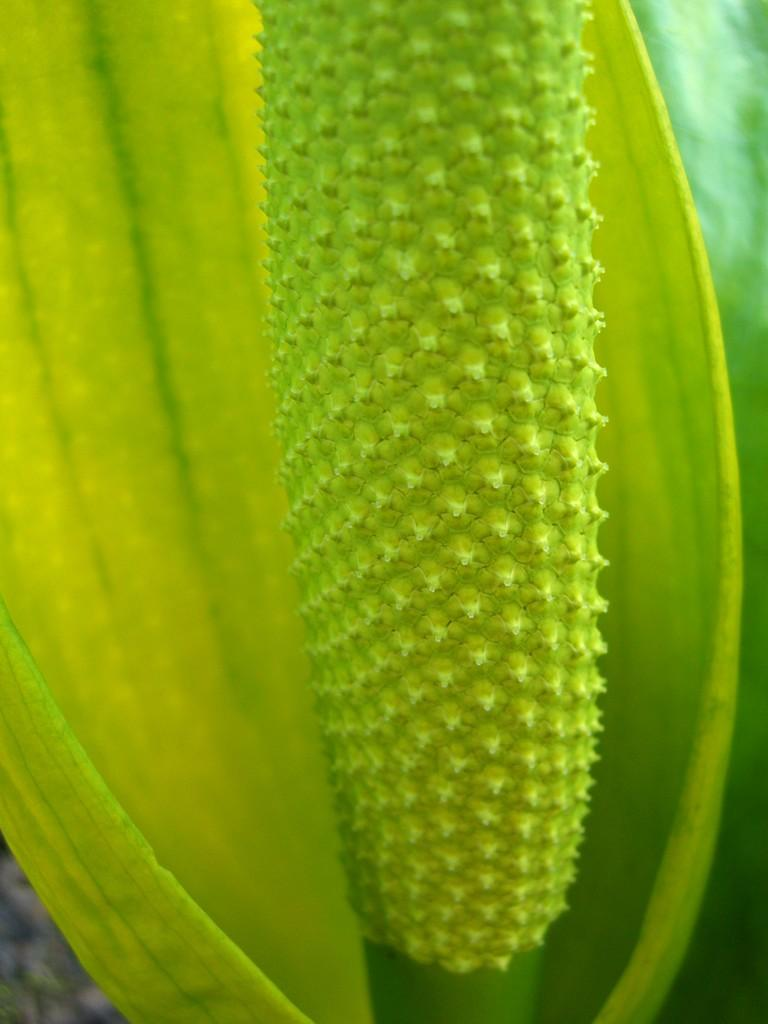What is present in the image? There is a plant and a leaf in the image. Can you describe the plant in the image? The plant in the image has a leaf. What is the appearance of the background in the image? The background of the image is blurred. What type of juice is being squeezed from the leaf in the image? There is no juice being squeezed from the leaf in the image; it is a static image of a plant and a leaf. 